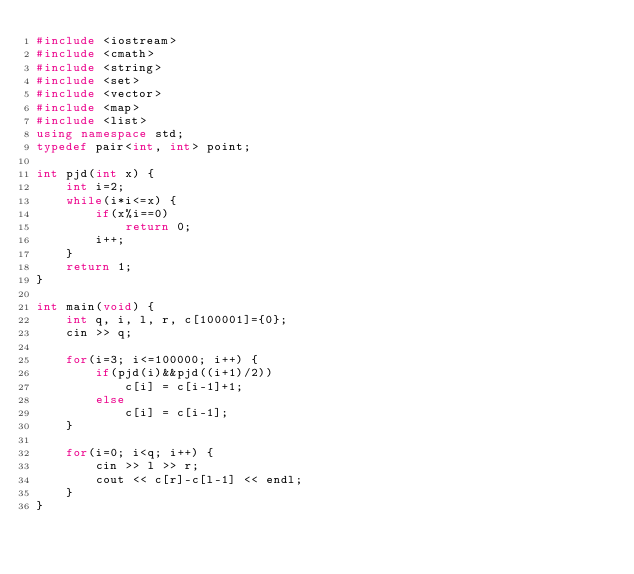Convert code to text. <code><loc_0><loc_0><loc_500><loc_500><_C++_>#include <iostream>
#include <cmath>
#include <string>
#include <set>
#include <vector>
#include <map>
#include <list>
using namespace std;
typedef pair<int, int> point;

int pjd(int x) {
    int i=2;
    while(i*i<=x) {
        if(x%i==0)
            return 0;
        i++;
    }
    return 1;
}

int main(void) {
    int q, i, l, r, c[100001]={0};
    cin >> q;
    
    for(i=3; i<=100000; i++) {
        if(pjd(i)&&pjd((i+1)/2))
            c[i] = c[i-1]+1;
        else
            c[i] = c[i-1];
    }
    
    for(i=0; i<q; i++) {
        cin >> l >> r;
        cout << c[r]-c[l-1] << endl;
    }
}
</code> 